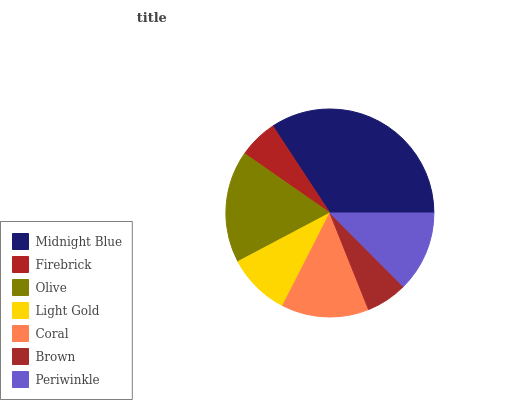Is Firebrick the minimum?
Answer yes or no. Yes. Is Midnight Blue the maximum?
Answer yes or no. Yes. Is Olive the minimum?
Answer yes or no. No. Is Olive the maximum?
Answer yes or no. No. Is Olive greater than Firebrick?
Answer yes or no. Yes. Is Firebrick less than Olive?
Answer yes or no. Yes. Is Firebrick greater than Olive?
Answer yes or no. No. Is Olive less than Firebrick?
Answer yes or no. No. Is Periwinkle the high median?
Answer yes or no. Yes. Is Periwinkle the low median?
Answer yes or no. Yes. Is Light Gold the high median?
Answer yes or no. No. Is Olive the low median?
Answer yes or no. No. 